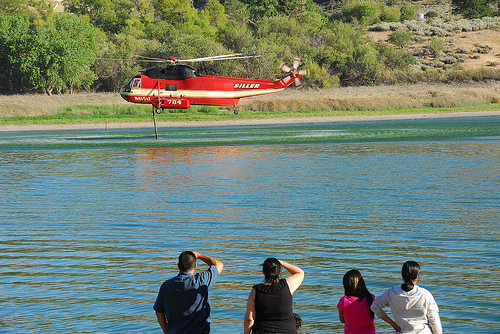<image>
Is there a helicopter above the water? Yes. The helicopter is positioned above the water in the vertical space, higher up in the scene. 